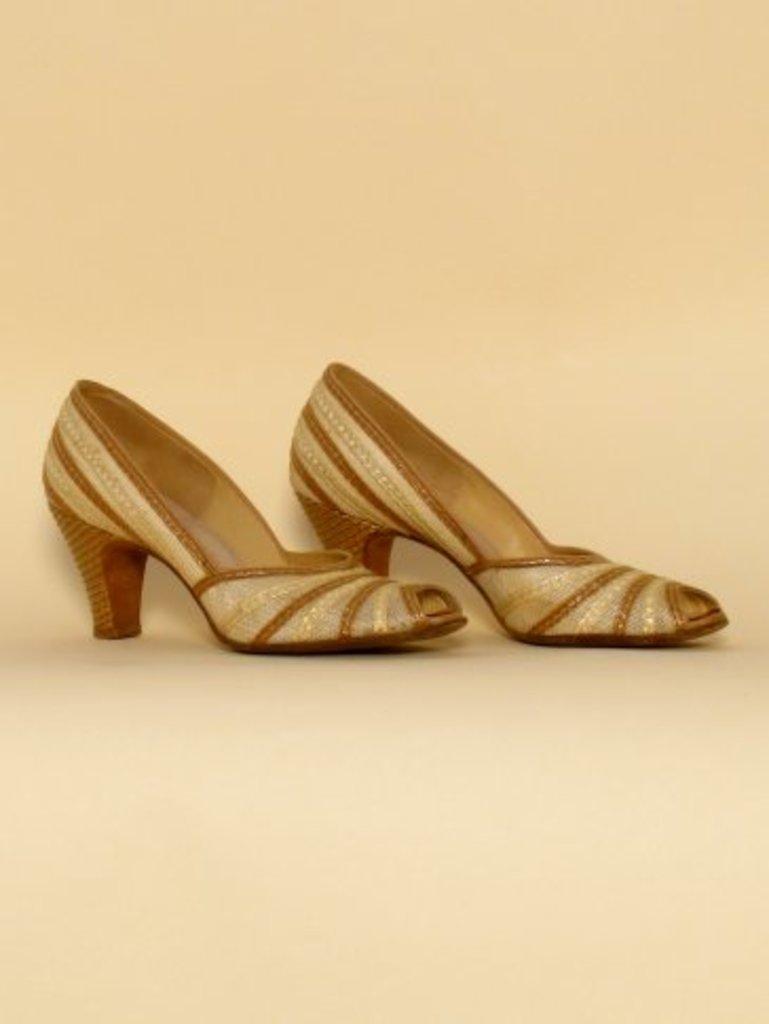In one or two sentences, can you explain what this image depicts? In this image I can see few golden colour heels. I can also see cream colour in the background. 